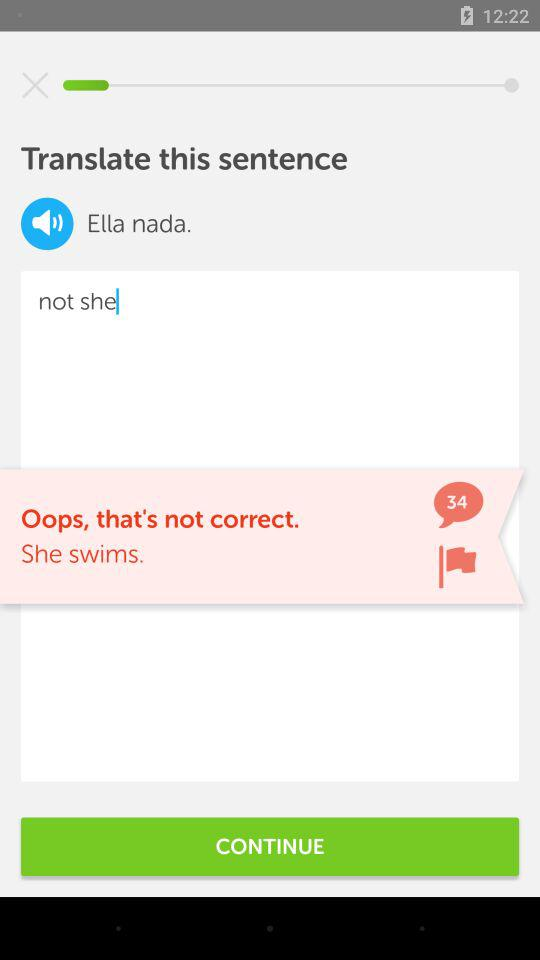How many comments are there? There are 34 comments. 